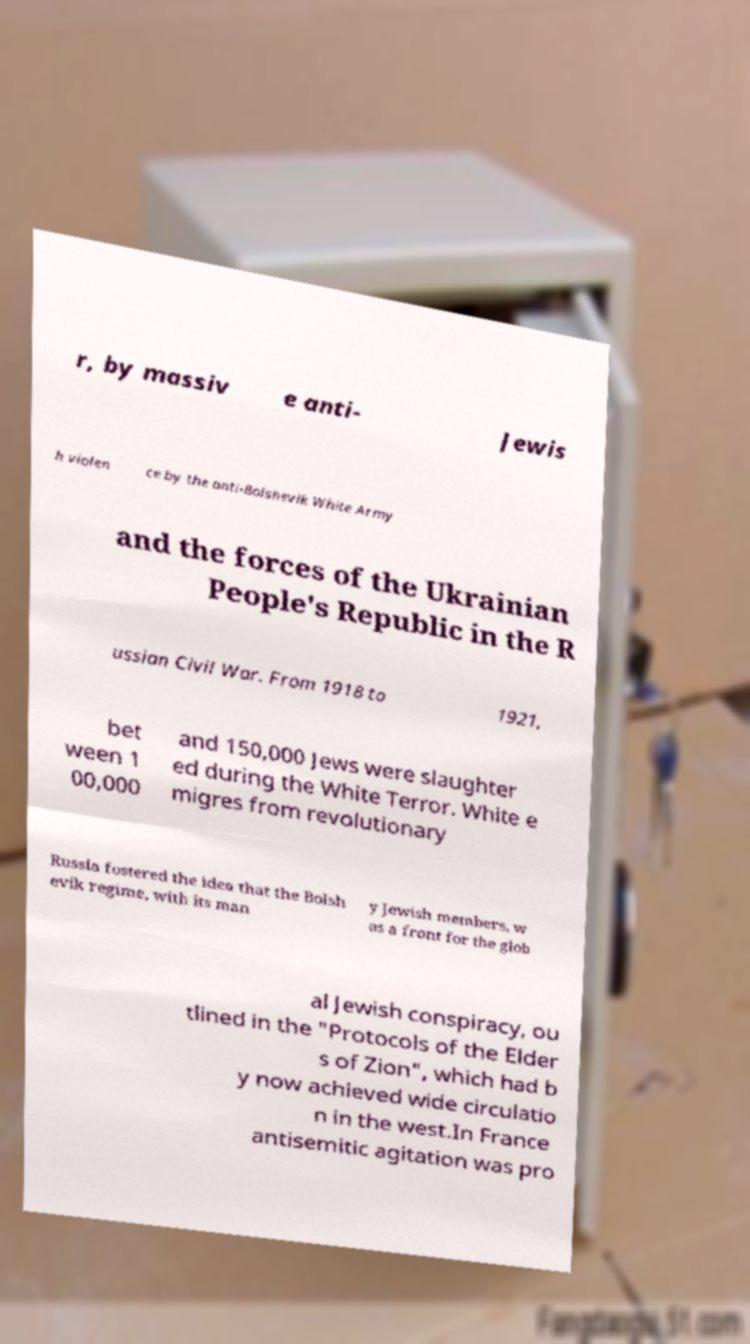For documentation purposes, I need the text within this image transcribed. Could you provide that? r, by massiv e anti- Jewis h violen ce by the anti-Bolshevik White Army and the forces of the Ukrainian People's Republic in the R ussian Civil War. From 1918 to 1921, bet ween 1 00,000 and 150,000 Jews were slaughter ed during the White Terror. White e migres from revolutionary Russia fostered the idea that the Bolsh evik regime, with its man y Jewish members, w as a front for the glob al Jewish conspiracy, ou tlined in the "Protocols of the Elder s of Zion", which had b y now achieved wide circulatio n in the west.In France antisemitic agitation was pro 